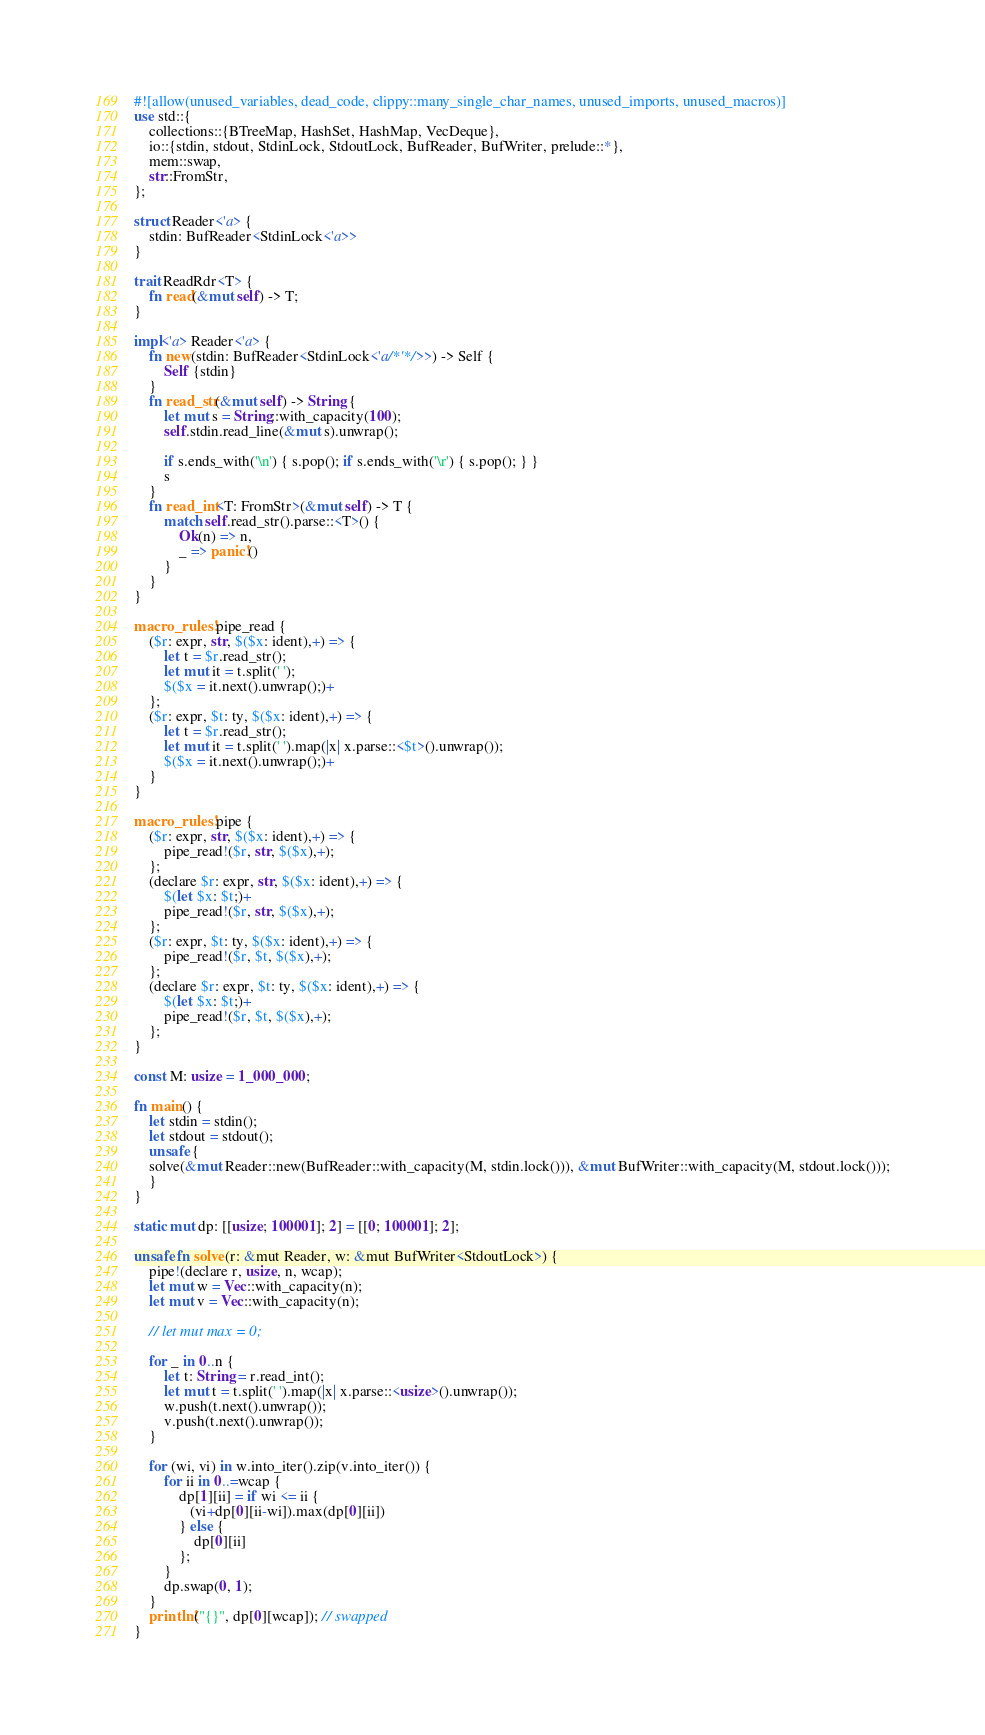Convert code to text. <code><loc_0><loc_0><loc_500><loc_500><_Rust_>#![allow(unused_variables, dead_code, clippy::many_single_char_names, unused_imports, unused_macros)]
use std::{
    collections::{BTreeMap, HashSet, HashMap, VecDeque},
    io::{stdin, stdout, StdinLock, StdoutLock, BufReader, BufWriter, prelude::*},
    mem::swap,
    str::FromStr,
};

struct Reader<'a> {
    stdin: BufReader<StdinLock<'a>>
}

trait ReadRdr<T> {
    fn read(&mut self) -> T;
}

impl<'a> Reader<'a> {
    fn new(stdin: BufReader<StdinLock<'a/*'*/>>) -> Self {
        Self {stdin}
    }
    fn read_str(&mut self) -> String {
        let mut s = String::with_capacity(100);
        self.stdin.read_line(&mut s).unwrap();

        if s.ends_with('\n') { s.pop(); if s.ends_with('\r') { s.pop(); } }
        s
    }
    fn read_int<T: FromStr>(&mut self) -> T {
        match self.read_str().parse::<T>() {
            Ok(n) => n,
            _ => panic!()
        }
    }
}

macro_rules! pipe_read {
    ($r: expr, str, $($x: ident),+) => {
        let t = $r.read_str();
        let mut it = t.split(' ');
        $($x = it.next().unwrap();)+
    };
    ($r: expr, $t: ty, $($x: ident),+) => {
        let t = $r.read_str();
        let mut it = t.split(' ').map(|x| x.parse::<$t>().unwrap());
        $($x = it.next().unwrap();)+
    }
}

macro_rules! pipe {
    ($r: expr, str, $($x: ident),+) => {
        pipe_read!($r, str, $($x),+);
    };
    (declare $r: expr, str, $($x: ident),+) => {
        $(let $x: $t;)+
        pipe_read!($r, str, $($x),+);
    };
    ($r: expr, $t: ty, $($x: ident),+) => {
        pipe_read!($r, $t, $($x),+);
    };
    (declare $r: expr, $t: ty, $($x: ident),+) => {
        $(let $x: $t;)+
        pipe_read!($r, $t, $($x),+);
    };
}

const M: usize = 1_000_000;

fn main() {
    let stdin = stdin();
    let stdout = stdout();
    unsafe {
    solve(&mut Reader::new(BufReader::with_capacity(M, stdin.lock())), &mut BufWriter::with_capacity(M, stdout.lock()));
    }
}

static mut dp: [[usize; 100001]; 2] = [[0; 100001]; 2];

unsafe fn solve(r: &mut Reader, w: &mut BufWriter<StdoutLock>) {
    pipe!(declare r, usize, n, wcap);
    let mut w = Vec::with_capacity(n);
    let mut v = Vec::with_capacity(n);

    // let mut max = 0;

    for _ in 0..n {
        let t: String = r.read_int();
        let mut t = t.split(' ').map(|x| x.parse::<usize>().unwrap());
        w.push(t.next().unwrap());
        v.push(t.next().unwrap());
    }

    for (wi, vi) in w.into_iter().zip(v.into_iter()) {
        for ii in 0..=wcap {
            dp[1][ii] = if wi <= ii {
               (vi+dp[0][ii-wi]).max(dp[0][ii])
            } else {
                dp[0][ii]
            };
        }
        dp.swap(0, 1);
    }
    println!("{}", dp[0][wcap]); // swapped
}
</code> 